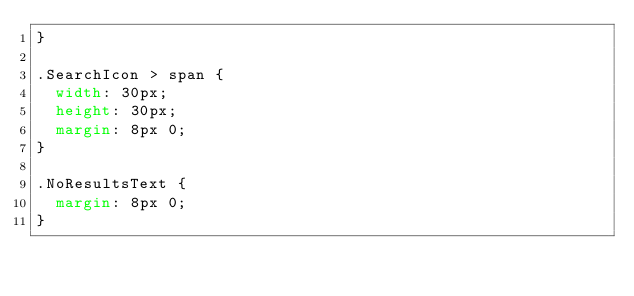Convert code to text. <code><loc_0><loc_0><loc_500><loc_500><_CSS_>}

.SearchIcon > span {
  width: 30px;
  height: 30px;
  margin: 8px 0;
}

.NoResultsText {
  margin: 8px 0;
}
</code> 